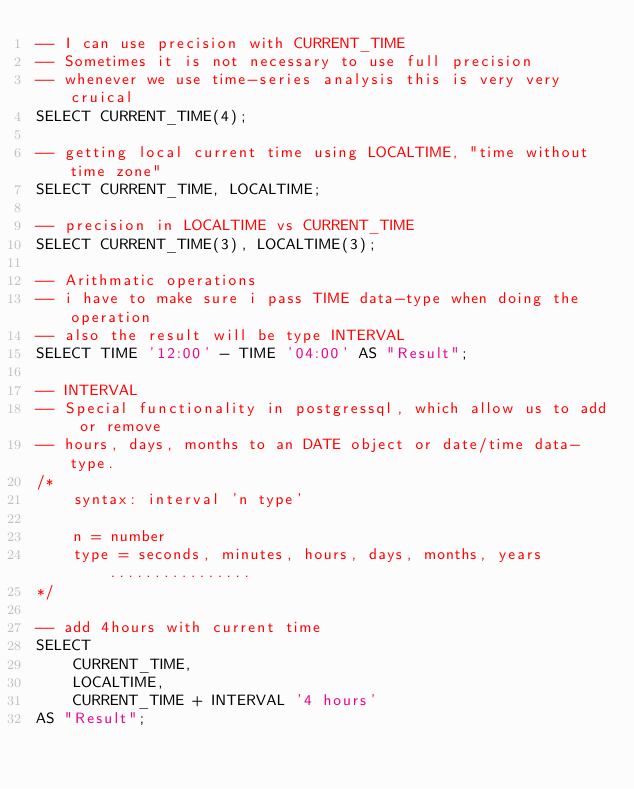<code> <loc_0><loc_0><loc_500><loc_500><_SQL_>-- I can use precision with CURRENT_TIME
-- Sometimes it is not necessary to use full precision
-- whenever we use time-series analysis this is very very cruical
SELECT CURRENT_TIME(4);

-- getting local current time using LOCALTIME, "time without time zone"
SELECT CURRENT_TIME, LOCALTIME;

-- precision in LOCALTIME vs CURRENT_TIME
SELECT CURRENT_TIME(3), LOCALTIME(3);

-- Arithmatic operations
-- i have to make sure i pass TIME data-type when doing the operation
-- also the result will be type INTERVAL
SELECT TIME '12:00' - TIME '04:00' AS "Result";

-- INTERVAL
-- Special functionality in postgressql, which allow us to add or remove
-- hours, days, months to an DATE object or date/time data-type.
/*
	syntax: interval 'n type'

	n = number
	type = seconds, minutes, hours, days, months, years ................
*/

-- add 4hours with current time
SELECT
	CURRENT_TIME,
	LOCALTIME,
	CURRENT_TIME + INTERVAL '4 hours'
AS "Result";</code> 